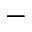<formula> <loc_0><loc_0><loc_500><loc_500>-</formula> 